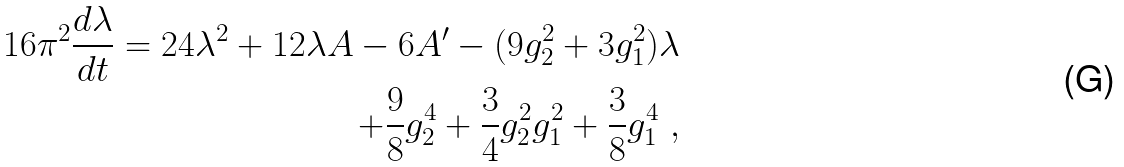Convert formula to latex. <formula><loc_0><loc_0><loc_500><loc_500>1 6 \pi ^ { 2 } { \frac { d \lambda } { d t } } = 2 4 \lambda ^ { 2 } + 1 2 \lambda A - 6 A ^ { \prime } - ( 9 g _ { 2 } ^ { 2 } + 3 g _ { 1 } ^ { 2 } ) \lambda \\ + { \frac { 9 } { 8 } } g _ { 2 } ^ { 4 } + { \frac { 3 } { 4 } } g _ { 2 } ^ { 2 } g _ { 1 } ^ { 2 } + { \frac { 3 } { 8 } } g _ { 1 } ^ { 4 } \ ,</formula> 